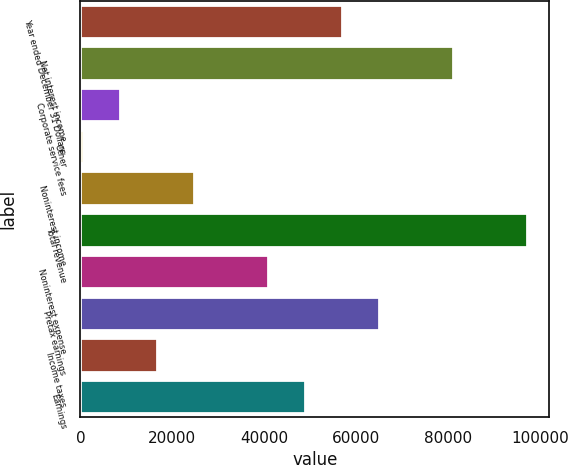<chart> <loc_0><loc_0><loc_500><loc_500><bar_chart><fcel>Year ended December 31 Dollars<fcel>Net interest income<fcel>Corporate service fees<fcel>Other<fcel>Noninterest income<fcel>Total revenue<fcel>Noninterest expense<fcel>Pretax earnings<fcel>Income taxes<fcel>Earnings<nl><fcel>56875.6<fcel>81043<fcel>8540.8<fcel>485<fcel>24652.4<fcel>97154.6<fcel>40764<fcel>64931.4<fcel>16596.6<fcel>48819.8<nl></chart> 